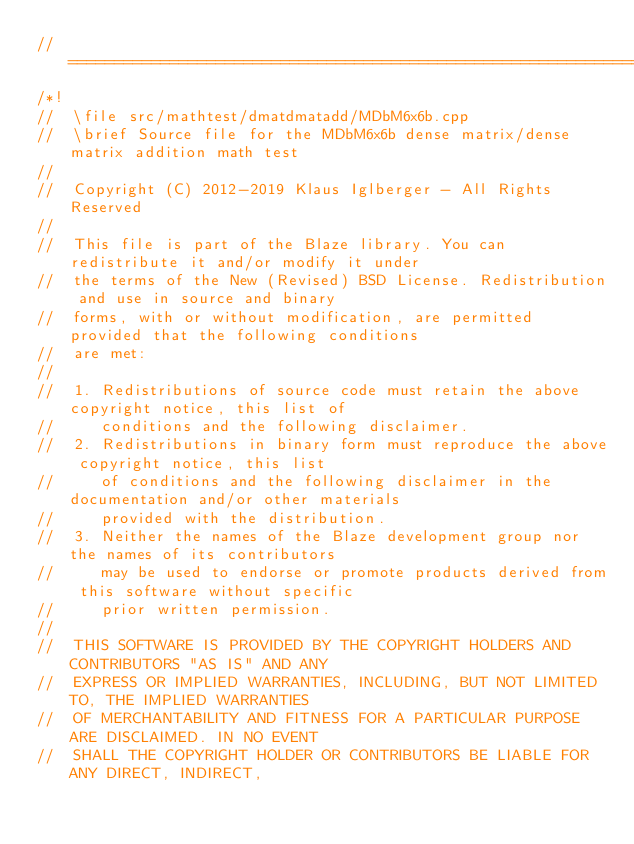Convert code to text. <code><loc_0><loc_0><loc_500><loc_500><_C++_>//=================================================================================================
/*!
//  \file src/mathtest/dmatdmatadd/MDbM6x6b.cpp
//  \brief Source file for the MDbM6x6b dense matrix/dense matrix addition math test
//
//  Copyright (C) 2012-2019 Klaus Iglberger - All Rights Reserved
//
//  This file is part of the Blaze library. You can redistribute it and/or modify it under
//  the terms of the New (Revised) BSD License. Redistribution and use in source and binary
//  forms, with or without modification, are permitted provided that the following conditions
//  are met:
//
//  1. Redistributions of source code must retain the above copyright notice, this list of
//     conditions and the following disclaimer.
//  2. Redistributions in binary form must reproduce the above copyright notice, this list
//     of conditions and the following disclaimer in the documentation and/or other materials
//     provided with the distribution.
//  3. Neither the names of the Blaze development group nor the names of its contributors
//     may be used to endorse or promote products derived from this software without specific
//     prior written permission.
//
//  THIS SOFTWARE IS PROVIDED BY THE COPYRIGHT HOLDERS AND CONTRIBUTORS "AS IS" AND ANY
//  EXPRESS OR IMPLIED WARRANTIES, INCLUDING, BUT NOT LIMITED TO, THE IMPLIED WARRANTIES
//  OF MERCHANTABILITY AND FITNESS FOR A PARTICULAR PURPOSE ARE DISCLAIMED. IN NO EVENT
//  SHALL THE COPYRIGHT HOLDER OR CONTRIBUTORS BE LIABLE FOR ANY DIRECT, INDIRECT,</code> 